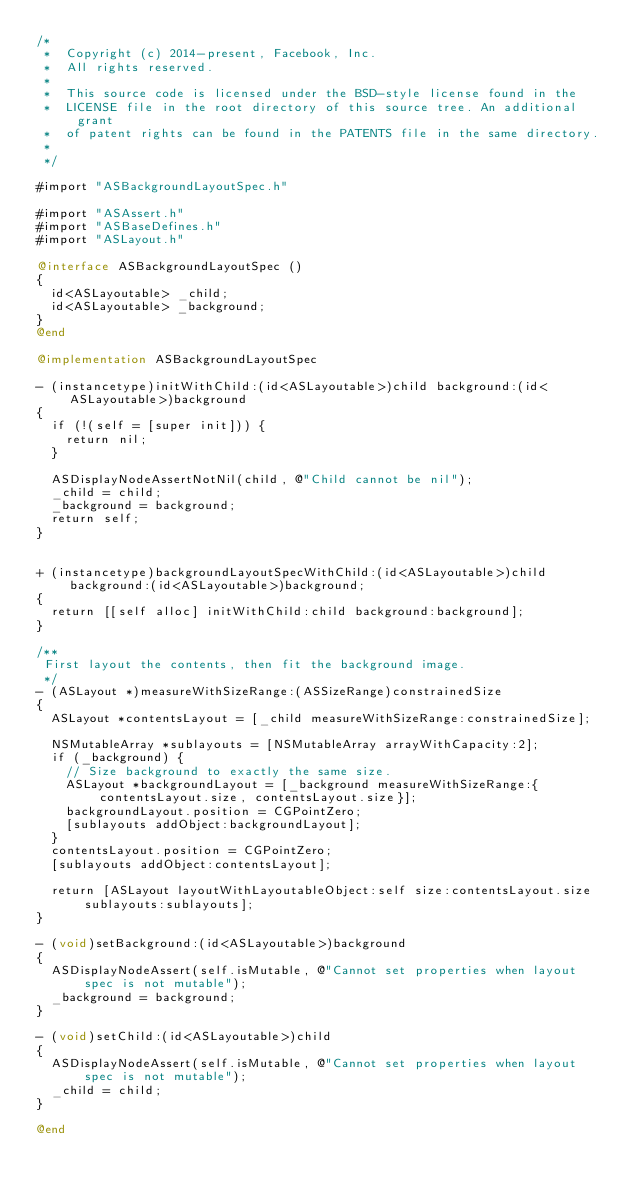Convert code to text. <code><loc_0><loc_0><loc_500><loc_500><_ObjectiveC_>/*
 *  Copyright (c) 2014-present, Facebook, Inc.
 *  All rights reserved.
 *
 *  This source code is licensed under the BSD-style license found in the
 *  LICENSE file in the root directory of this source tree. An additional grant
 *  of patent rights can be found in the PATENTS file in the same directory.
 *
 */

#import "ASBackgroundLayoutSpec.h"

#import "ASAssert.h"
#import "ASBaseDefines.h"
#import "ASLayout.h"

@interface ASBackgroundLayoutSpec ()
{
  id<ASLayoutable> _child;
  id<ASLayoutable> _background;
}
@end

@implementation ASBackgroundLayoutSpec

- (instancetype)initWithChild:(id<ASLayoutable>)child background:(id<ASLayoutable>)background
{
  if (!(self = [super init])) {
    return nil;
  }
  
  ASDisplayNodeAssertNotNil(child, @"Child cannot be nil");
  _child = child;
  _background = background;
  return self;
}


+ (instancetype)backgroundLayoutSpecWithChild:(id<ASLayoutable>)child background:(id<ASLayoutable>)background;
{
  return [[self alloc] initWithChild:child background:background];
}

/**
 First layout the contents, then fit the background image.
 */
- (ASLayout *)measureWithSizeRange:(ASSizeRange)constrainedSize
{
  ASLayout *contentsLayout = [_child measureWithSizeRange:constrainedSize];

  NSMutableArray *sublayouts = [NSMutableArray arrayWithCapacity:2];
  if (_background) {
    // Size background to exactly the same size.
    ASLayout *backgroundLayout = [_background measureWithSizeRange:{contentsLayout.size, contentsLayout.size}];
    backgroundLayout.position = CGPointZero;
    [sublayouts addObject:backgroundLayout];
  }
  contentsLayout.position = CGPointZero;
  [sublayouts addObject:contentsLayout];

  return [ASLayout layoutWithLayoutableObject:self size:contentsLayout.size sublayouts:sublayouts];
}

- (void)setBackground:(id<ASLayoutable>)background
{
  ASDisplayNodeAssert(self.isMutable, @"Cannot set properties when layout spec is not mutable");
  _background = background;
}

- (void)setChild:(id<ASLayoutable>)child
{
  ASDisplayNodeAssert(self.isMutable, @"Cannot set properties when layout spec is not mutable");
  _child = child;
}

@end
</code> 